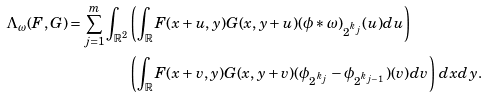Convert formula to latex. <formula><loc_0><loc_0><loc_500><loc_500>\Lambda _ { \omega } ( F , G ) = \sum _ { j = 1 } ^ { m } \int _ { \mathbb { R } ^ { 2 } } & \left ( \int _ { \mathbb { R } } F ( x + u , y ) G ( x , y + u ) ( \phi \ast \omega ) _ { 2 ^ { k _ { j } } } ( u ) d u \right ) \\ & \left ( \int _ { \mathbb { R } } F ( x + v , y ) G ( x , y + v ) ( \phi _ { 2 ^ { k _ { j } } } - \phi _ { 2 ^ { k _ { j - 1 } } } ) ( v ) d v \right ) \, d x d y .</formula> 